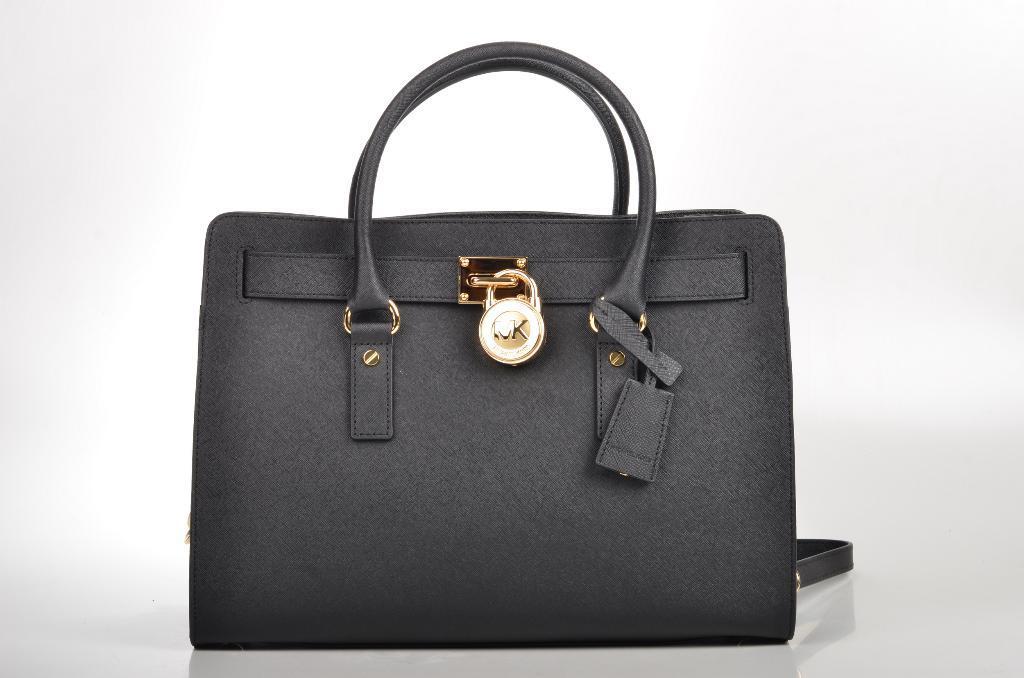How would you summarize this image in a sentence or two? In this image i can see a bag. 